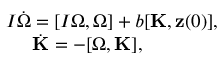Convert formula to latex. <formula><loc_0><loc_0><loc_500><loc_500>\begin{array} { r } { I \dot { \boldsymbol \Omega } = [ I { \boldsymbol \Omega } , { \boldsymbol \Omega } ] + b [ { K } , { z } ( 0 ) ] , } \\ { \dot { K } = - [ { \boldsymbol \Omega } , { K } ] , \quad } \end{array}</formula> 